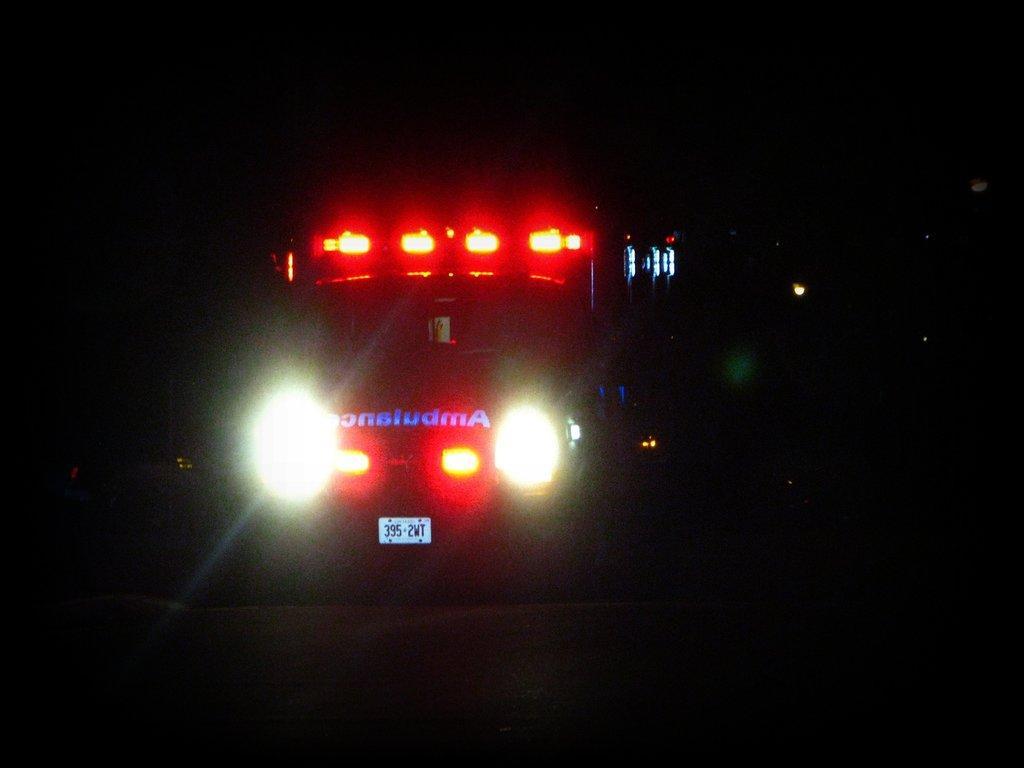Could you give a brief overview of what you see in this image? In this image we can see a vehicle with some lights and a number plate, also we can see the background is dark. 